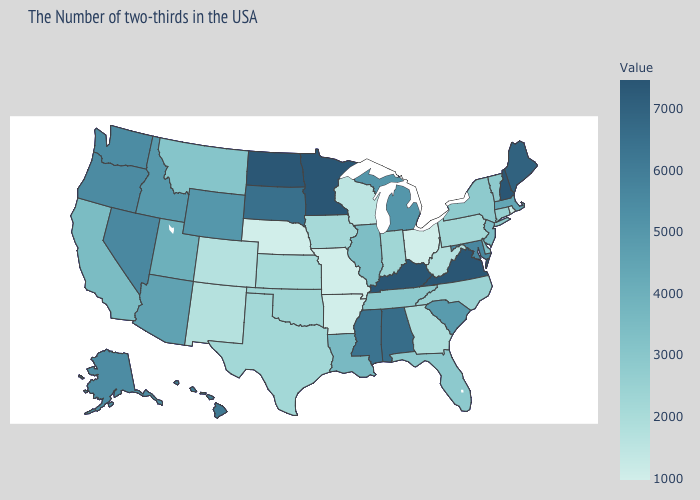Does South Dakota have a lower value than Minnesota?
Quick response, please. Yes. Does North Carolina have a higher value than West Virginia?
Give a very brief answer. Yes. Is the legend a continuous bar?
Short answer required. Yes. Does Arizona have the lowest value in the USA?
Concise answer only. No. Among the states that border Ohio , which have the lowest value?
Concise answer only. West Virginia. Among the states that border Florida , does Alabama have the lowest value?
Keep it brief. No. 